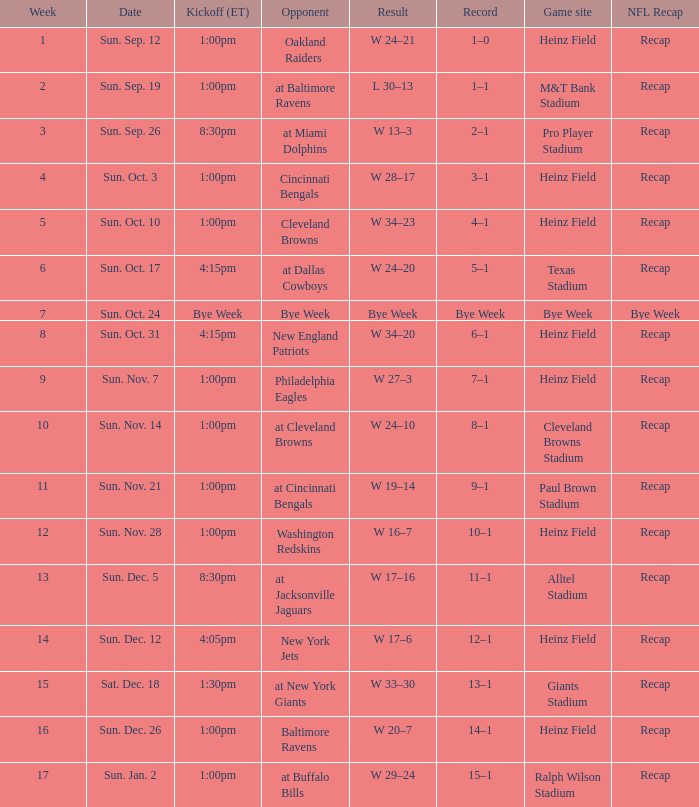Which gaming platform features a 1:00 pm (et) kickoff and a 4-1 win-loss ratio? Heinz Field. Help me parse the entirety of this table. {'header': ['Week', 'Date', 'Kickoff (ET)', 'Opponent', 'Result', 'Record', 'Game site', 'NFL Recap'], 'rows': [['1', 'Sun. Sep. 12', '1:00pm', 'Oakland Raiders', 'W 24–21', '1–0', 'Heinz Field', 'Recap'], ['2', 'Sun. Sep. 19', '1:00pm', 'at Baltimore Ravens', 'L 30–13', '1–1', 'M&T Bank Stadium', 'Recap'], ['3', 'Sun. Sep. 26', '8:30pm', 'at Miami Dolphins', 'W 13–3', '2–1', 'Pro Player Stadium', 'Recap'], ['4', 'Sun. Oct. 3', '1:00pm', 'Cincinnati Bengals', 'W 28–17', '3–1', 'Heinz Field', 'Recap'], ['5', 'Sun. Oct. 10', '1:00pm', 'Cleveland Browns', 'W 34–23', '4–1', 'Heinz Field', 'Recap'], ['6', 'Sun. Oct. 17', '4:15pm', 'at Dallas Cowboys', 'W 24–20', '5–1', 'Texas Stadium', 'Recap'], ['7', 'Sun. Oct. 24', 'Bye Week', 'Bye Week', 'Bye Week', 'Bye Week', 'Bye Week', 'Bye Week'], ['8', 'Sun. Oct. 31', '4:15pm', 'New England Patriots', 'W 34–20', '6–1', 'Heinz Field', 'Recap'], ['9', 'Sun. Nov. 7', '1:00pm', 'Philadelphia Eagles', 'W 27–3', '7–1', 'Heinz Field', 'Recap'], ['10', 'Sun. Nov. 14', '1:00pm', 'at Cleveland Browns', 'W 24–10', '8–1', 'Cleveland Browns Stadium', 'Recap'], ['11', 'Sun. Nov. 21', '1:00pm', 'at Cincinnati Bengals', 'W 19–14', '9–1', 'Paul Brown Stadium', 'Recap'], ['12', 'Sun. Nov. 28', '1:00pm', 'Washington Redskins', 'W 16–7', '10–1', 'Heinz Field', 'Recap'], ['13', 'Sun. Dec. 5', '8:30pm', 'at Jacksonville Jaguars', 'W 17–16', '11–1', 'Alltel Stadium', 'Recap'], ['14', 'Sun. Dec. 12', '4:05pm', 'New York Jets', 'W 17–6', '12–1', 'Heinz Field', 'Recap'], ['15', 'Sat. Dec. 18', '1:30pm', 'at New York Giants', 'W 33–30', '13–1', 'Giants Stadium', 'Recap'], ['16', 'Sun. Dec. 26', '1:00pm', 'Baltimore Ravens', 'W 20–7', '14–1', 'Heinz Field', 'Recap'], ['17', 'Sun. Jan. 2', '1:00pm', 'at Buffalo Bills', 'W 29–24', '15–1', 'Ralph Wilson Stadium', 'Recap']]} 